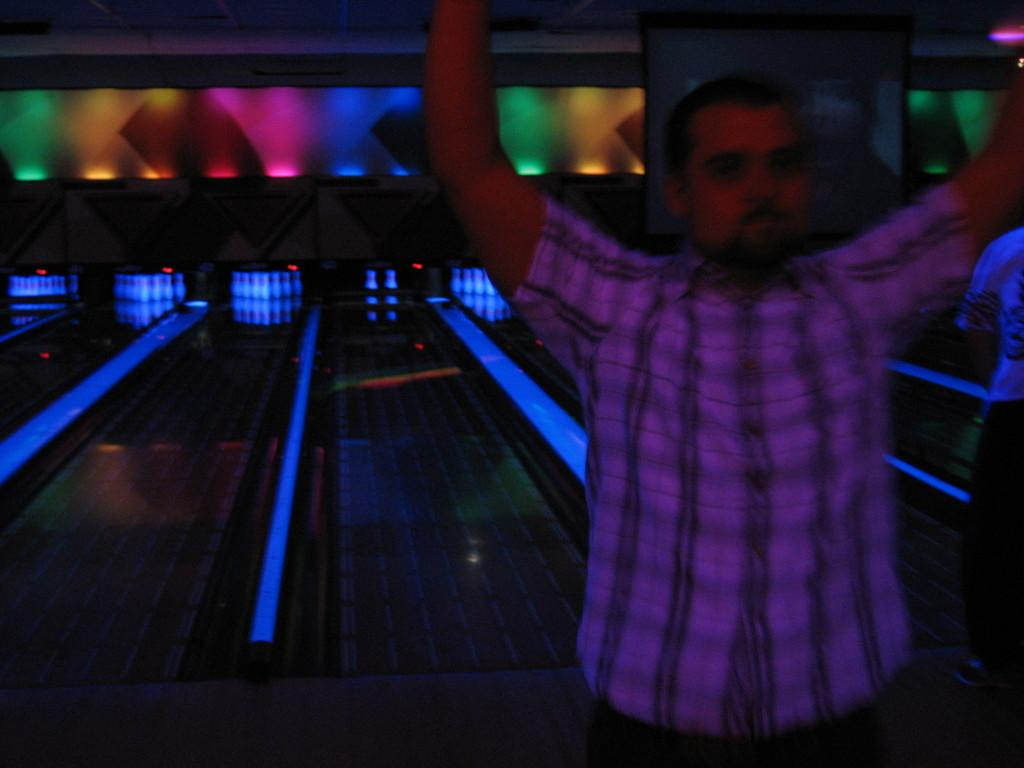What is the person in the foreground of the image doing? The person is cheering in the foreground of the image. What can be seen in the background of the image? There is a bowling platform in the background of the image. What is the source of light in the background of the image? There is light visible in the background of the image. What is the structure at the top of the image? There is a wall at the top of the image. What type of pancake is being flipped on the bowling platform in the image? There is no pancake present in the image, and the bowling platform is not being used for cooking. 